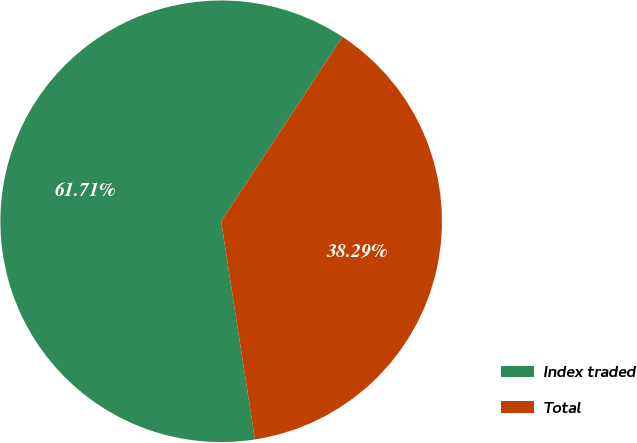Convert chart to OTSL. <chart><loc_0><loc_0><loc_500><loc_500><pie_chart><fcel>Index traded<fcel>Total<nl><fcel>61.71%<fcel>38.29%<nl></chart> 